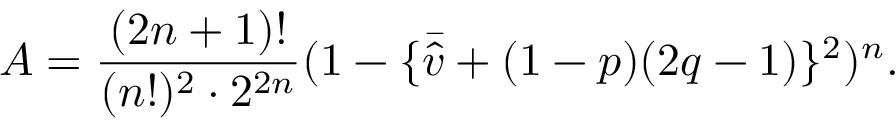Convert formula to latex. <formula><loc_0><loc_0><loc_500><loc_500>A = \frac { ( 2 n + 1 ) ! } { ( n ! ) ^ { 2 } \cdot 2 ^ { 2 n } } ( 1 - \{ \bar { \hat { v } } + ( 1 - p ) ( 2 q - 1 ) \} ^ { 2 } ) ^ { n } .</formula> 